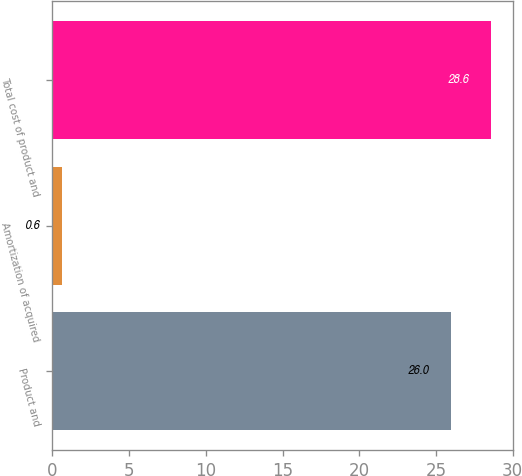Convert chart to OTSL. <chart><loc_0><loc_0><loc_500><loc_500><bar_chart><fcel>Product and<fcel>Amortization of acquired<fcel>Total cost of product and<nl><fcel>26<fcel>0.6<fcel>28.6<nl></chart> 